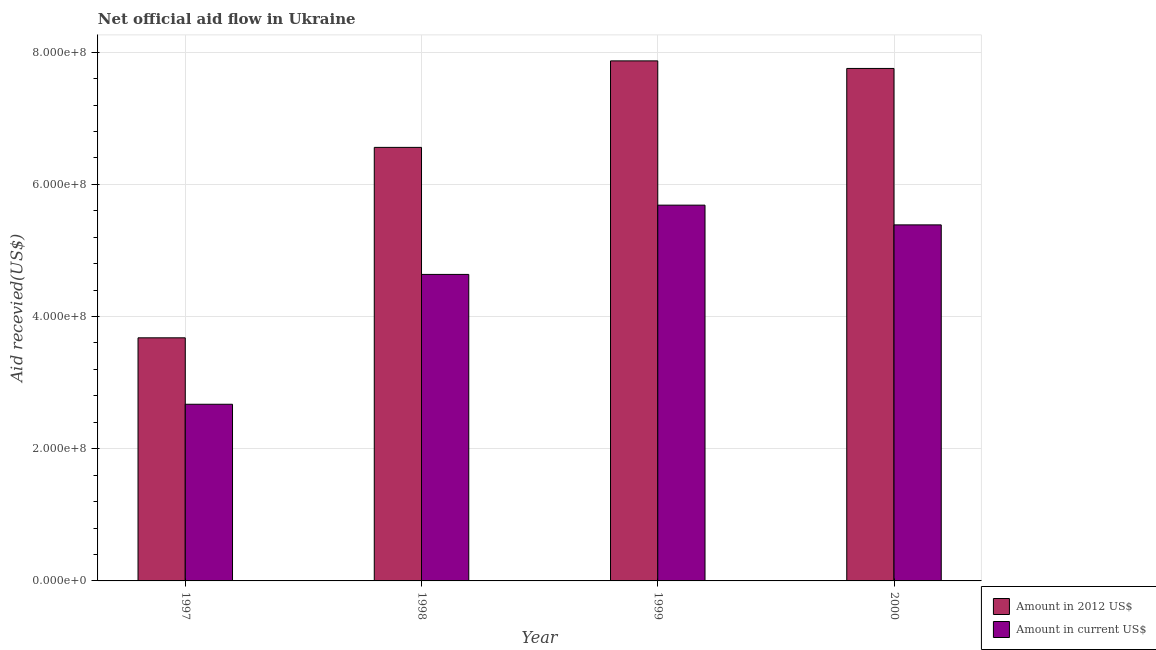How many different coloured bars are there?
Give a very brief answer. 2. What is the label of the 1st group of bars from the left?
Give a very brief answer. 1997. What is the amount of aid received(expressed in 2012 us$) in 1997?
Keep it short and to the point. 3.68e+08. Across all years, what is the maximum amount of aid received(expressed in 2012 us$)?
Give a very brief answer. 7.87e+08. Across all years, what is the minimum amount of aid received(expressed in us$)?
Your response must be concise. 2.67e+08. What is the total amount of aid received(expressed in 2012 us$) in the graph?
Your answer should be compact. 2.59e+09. What is the difference between the amount of aid received(expressed in us$) in 1997 and that in 2000?
Your response must be concise. -2.71e+08. What is the difference between the amount of aid received(expressed in 2012 us$) in 2000 and the amount of aid received(expressed in us$) in 1998?
Give a very brief answer. 1.19e+08. What is the average amount of aid received(expressed in us$) per year?
Your answer should be compact. 4.60e+08. In the year 1998, what is the difference between the amount of aid received(expressed in 2012 us$) and amount of aid received(expressed in us$)?
Your answer should be compact. 0. In how many years, is the amount of aid received(expressed in 2012 us$) greater than 560000000 US$?
Your response must be concise. 3. What is the ratio of the amount of aid received(expressed in 2012 us$) in 1998 to that in 1999?
Make the answer very short. 0.83. Is the amount of aid received(expressed in us$) in 1999 less than that in 2000?
Offer a very short reply. No. What is the difference between the highest and the second highest amount of aid received(expressed in 2012 us$)?
Ensure brevity in your answer.  1.14e+07. What is the difference between the highest and the lowest amount of aid received(expressed in us$)?
Your answer should be very brief. 3.01e+08. Is the sum of the amount of aid received(expressed in us$) in 1997 and 2000 greater than the maximum amount of aid received(expressed in 2012 us$) across all years?
Your answer should be very brief. Yes. What does the 2nd bar from the left in 1999 represents?
Offer a very short reply. Amount in current US$. What does the 2nd bar from the right in 2000 represents?
Keep it short and to the point. Amount in 2012 US$. How many bars are there?
Ensure brevity in your answer.  8. What is the difference between two consecutive major ticks on the Y-axis?
Make the answer very short. 2.00e+08. Does the graph contain any zero values?
Make the answer very short. No. Does the graph contain grids?
Ensure brevity in your answer.  Yes. Where does the legend appear in the graph?
Give a very brief answer. Bottom right. What is the title of the graph?
Your response must be concise. Net official aid flow in Ukraine. What is the label or title of the X-axis?
Give a very brief answer. Year. What is the label or title of the Y-axis?
Your response must be concise. Aid recevied(US$). What is the Aid recevied(US$) of Amount in 2012 US$ in 1997?
Your response must be concise. 3.68e+08. What is the Aid recevied(US$) in Amount in current US$ in 1997?
Offer a very short reply. 2.67e+08. What is the Aid recevied(US$) in Amount in 2012 US$ in 1998?
Provide a short and direct response. 6.56e+08. What is the Aid recevied(US$) in Amount in current US$ in 1998?
Your response must be concise. 4.64e+08. What is the Aid recevied(US$) of Amount in 2012 US$ in 1999?
Your answer should be compact. 7.87e+08. What is the Aid recevied(US$) of Amount in current US$ in 1999?
Offer a terse response. 5.69e+08. What is the Aid recevied(US$) in Amount in 2012 US$ in 2000?
Offer a terse response. 7.75e+08. What is the Aid recevied(US$) of Amount in current US$ in 2000?
Offer a terse response. 5.39e+08. Across all years, what is the maximum Aid recevied(US$) in Amount in 2012 US$?
Ensure brevity in your answer.  7.87e+08. Across all years, what is the maximum Aid recevied(US$) in Amount in current US$?
Provide a succinct answer. 5.69e+08. Across all years, what is the minimum Aid recevied(US$) in Amount in 2012 US$?
Your response must be concise. 3.68e+08. Across all years, what is the minimum Aid recevied(US$) in Amount in current US$?
Your response must be concise. 2.67e+08. What is the total Aid recevied(US$) of Amount in 2012 US$ in the graph?
Ensure brevity in your answer.  2.59e+09. What is the total Aid recevied(US$) of Amount in current US$ in the graph?
Ensure brevity in your answer.  1.84e+09. What is the difference between the Aid recevied(US$) of Amount in 2012 US$ in 1997 and that in 1998?
Keep it short and to the point. -2.88e+08. What is the difference between the Aid recevied(US$) in Amount in current US$ in 1997 and that in 1998?
Offer a terse response. -1.96e+08. What is the difference between the Aid recevied(US$) in Amount in 2012 US$ in 1997 and that in 1999?
Make the answer very short. -4.19e+08. What is the difference between the Aid recevied(US$) in Amount in current US$ in 1997 and that in 1999?
Your answer should be compact. -3.01e+08. What is the difference between the Aid recevied(US$) of Amount in 2012 US$ in 1997 and that in 2000?
Your answer should be very brief. -4.08e+08. What is the difference between the Aid recevied(US$) in Amount in current US$ in 1997 and that in 2000?
Offer a terse response. -2.71e+08. What is the difference between the Aid recevied(US$) in Amount in 2012 US$ in 1998 and that in 1999?
Offer a very short reply. -1.31e+08. What is the difference between the Aid recevied(US$) in Amount in current US$ in 1998 and that in 1999?
Your answer should be compact. -1.05e+08. What is the difference between the Aid recevied(US$) in Amount in 2012 US$ in 1998 and that in 2000?
Provide a short and direct response. -1.19e+08. What is the difference between the Aid recevied(US$) of Amount in current US$ in 1998 and that in 2000?
Your response must be concise. -7.50e+07. What is the difference between the Aid recevied(US$) of Amount in 2012 US$ in 1999 and that in 2000?
Give a very brief answer. 1.14e+07. What is the difference between the Aid recevied(US$) in Amount in current US$ in 1999 and that in 2000?
Your answer should be compact. 2.98e+07. What is the difference between the Aid recevied(US$) of Amount in 2012 US$ in 1997 and the Aid recevied(US$) of Amount in current US$ in 1998?
Offer a terse response. -9.59e+07. What is the difference between the Aid recevied(US$) in Amount in 2012 US$ in 1997 and the Aid recevied(US$) in Amount in current US$ in 1999?
Your answer should be compact. -2.01e+08. What is the difference between the Aid recevied(US$) of Amount in 2012 US$ in 1997 and the Aid recevied(US$) of Amount in current US$ in 2000?
Your answer should be very brief. -1.71e+08. What is the difference between the Aid recevied(US$) of Amount in 2012 US$ in 1998 and the Aid recevied(US$) of Amount in current US$ in 1999?
Give a very brief answer. 8.74e+07. What is the difference between the Aid recevied(US$) of Amount in 2012 US$ in 1998 and the Aid recevied(US$) of Amount in current US$ in 2000?
Provide a succinct answer. 1.17e+08. What is the difference between the Aid recevied(US$) of Amount in 2012 US$ in 1999 and the Aid recevied(US$) of Amount in current US$ in 2000?
Offer a very short reply. 2.48e+08. What is the average Aid recevied(US$) in Amount in 2012 US$ per year?
Offer a terse response. 6.47e+08. What is the average Aid recevied(US$) in Amount in current US$ per year?
Your response must be concise. 4.60e+08. In the year 1997, what is the difference between the Aid recevied(US$) in Amount in 2012 US$ and Aid recevied(US$) in Amount in current US$?
Offer a terse response. 1.01e+08. In the year 1998, what is the difference between the Aid recevied(US$) in Amount in 2012 US$ and Aid recevied(US$) in Amount in current US$?
Keep it short and to the point. 1.92e+08. In the year 1999, what is the difference between the Aid recevied(US$) in Amount in 2012 US$ and Aid recevied(US$) in Amount in current US$?
Keep it short and to the point. 2.18e+08. In the year 2000, what is the difference between the Aid recevied(US$) in Amount in 2012 US$ and Aid recevied(US$) in Amount in current US$?
Offer a terse response. 2.37e+08. What is the ratio of the Aid recevied(US$) of Amount in 2012 US$ in 1997 to that in 1998?
Offer a very short reply. 0.56. What is the ratio of the Aid recevied(US$) of Amount in current US$ in 1997 to that in 1998?
Keep it short and to the point. 0.58. What is the ratio of the Aid recevied(US$) in Amount in 2012 US$ in 1997 to that in 1999?
Offer a terse response. 0.47. What is the ratio of the Aid recevied(US$) in Amount in current US$ in 1997 to that in 1999?
Your response must be concise. 0.47. What is the ratio of the Aid recevied(US$) in Amount in 2012 US$ in 1997 to that in 2000?
Keep it short and to the point. 0.47. What is the ratio of the Aid recevied(US$) of Amount in current US$ in 1997 to that in 2000?
Give a very brief answer. 0.5. What is the ratio of the Aid recevied(US$) of Amount in 2012 US$ in 1998 to that in 1999?
Your answer should be very brief. 0.83. What is the ratio of the Aid recevied(US$) in Amount in current US$ in 1998 to that in 1999?
Keep it short and to the point. 0.82. What is the ratio of the Aid recevied(US$) of Amount in 2012 US$ in 1998 to that in 2000?
Make the answer very short. 0.85. What is the ratio of the Aid recevied(US$) in Amount in current US$ in 1998 to that in 2000?
Your response must be concise. 0.86. What is the ratio of the Aid recevied(US$) in Amount in 2012 US$ in 1999 to that in 2000?
Keep it short and to the point. 1.01. What is the ratio of the Aid recevied(US$) of Amount in current US$ in 1999 to that in 2000?
Your answer should be very brief. 1.06. What is the difference between the highest and the second highest Aid recevied(US$) in Amount in 2012 US$?
Offer a very short reply. 1.14e+07. What is the difference between the highest and the second highest Aid recevied(US$) of Amount in current US$?
Offer a very short reply. 2.98e+07. What is the difference between the highest and the lowest Aid recevied(US$) of Amount in 2012 US$?
Keep it short and to the point. 4.19e+08. What is the difference between the highest and the lowest Aid recevied(US$) of Amount in current US$?
Provide a succinct answer. 3.01e+08. 